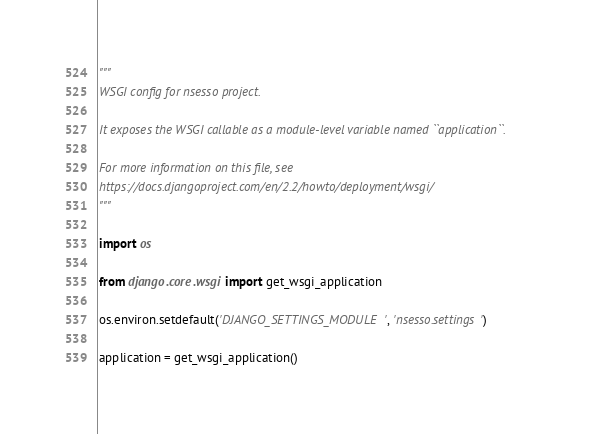Convert code to text. <code><loc_0><loc_0><loc_500><loc_500><_Python_>"""
WSGI config for nsesso project.

It exposes the WSGI callable as a module-level variable named ``application``.

For more information on this file, see
https://docs.djangoproject.com/en/2.2/howto/deployment/wsgi/
"""

import os

from django.core.wsgi import get_wsgi_application

os.environ.setdefault('DJANGO_SETTINGS_MODULE', 'nsesso.settings')

application = get_wsgi_application()
</code> 